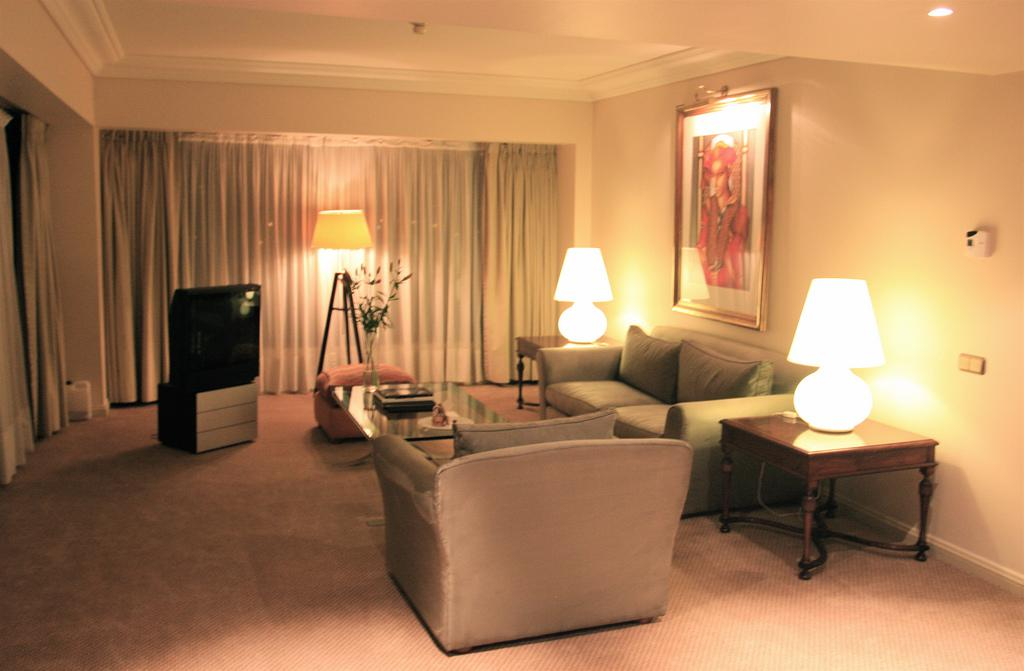Question: how many lamps are in the room?
Choices:
A. Four.
B. Two.
C. Three.
D. None.
Answer with the letter. Answer: C Question: what color is the chair?
Choices:
A. Tan.
B. Red.
C. Brown.
D. Green.
Answer with the letter. Answer: A Question: who would like this room?
Choices:
A. Someone into contemporary decorating.
B. Someone with young children.
C. Someone with good taste.
D. Someone with eclectic taste.
Answer with the letter. Answer: C Question: when is the television turned off?
Choices:
A. In ten minutes.
B. Right now.
C. In twenty minutes.
D. After lunch.
Answer with the letter. Answer: B Question: where was the photo taken?
Choices:
A. In the kitchen.
B. At the park.
C. In the airport.
D. Living room.
Answer with the letter. Answer: D Question: where is it hanging?
Choices:
A. On the wall.
B. From the ceiling.
C. From the streetlight.
D. From the telephone pole.
Answer with the letter. Answer: A Question: how many lamps?
Choices:
A. 2.
B. 3.
C. 4.
D. 5.
Answer with the letter. Answer: B Question: where are the lamps?
Choices:
A. In the garage.
B. Around the room.
C. In the kitchen.
D. At the repair shop.
Answer with the letter. Answer: B Question: what is on the coffee table?
Choices:
A. A stack of books.
B. A flower arrangement.
C. Some board games.
D. A television remote control.
Answer with the letter. Answer: B Question: how many lamps are table lamps?
Choices:
A. Two.
B. One.
C. Three.
D. Four.
Answer with the letter. Answer: A Question: how many lamps are floor lamps?
Choices:
A. Two.
B. One.
C. Three.
D. Four.
Answer with the letter. Answer: B Question: what color are the walls?
Choices:
A. Light silver color.
B. Light grey color.
C. Light cream color.
D. Light tan color.
Answer with the letter. Answer: C Question: how is the artwork mounted?
Choices:
A. On a wooden plaque.
B. With tape.
C. In a large frame.
D. On a hook.
Answer with the letter. Answer: C Question: what color is the frame?
Choices:
A. Gold.
B. Brown.
C. Black.
D. White.
Answer with the letter. Answer: A Question: what color is the rug?
Choices:
A. Beige.
B. Cream.
C. White.
D. Tan.
Answer with the letter. Answer: D Question: how many lamps are in the room?
Choices:
A. Three.
B. Two.
C. Four.
D. Five.
Answer with the letter. Answer: A Question: what is behind the tv?
Choices:
A. A photo.
B. A plastic container.
C. A lamp.
D. A plant.
Answer with the letter. Answer: B Question: what is given off by the lamps?
Choices:
A. A great deal of light.
B. A yellow glow.
C. A greenish hue.
D. Heat.
Answer with the letter. Answer: A Question: what is the television doing?
Choices:
A. It is "snowy.".
B. It is showing a news program.
C. It is just sitting there.
D. It is turned off.
Answer with the letter. Answer: D Question: what does the base of the lamp resemble?
Choices:
A. A hand.
B. A flower pot.
C. A tripod.
D. A loaf of bread.
Answer with the letter. Answer: C Question: what pieces of furniture are identical?
Choices:
A. The coffee tables.
B. The night stands.
C. The end tables.
D. The twin beds.
Answer with the letter. Answer: C Question: what type of ceiling does this room have?
Choices:
A. Stucco.
B. Tin.
C. Vaulted.
D. Cathedral.
Answer with the letter. Answer: C 